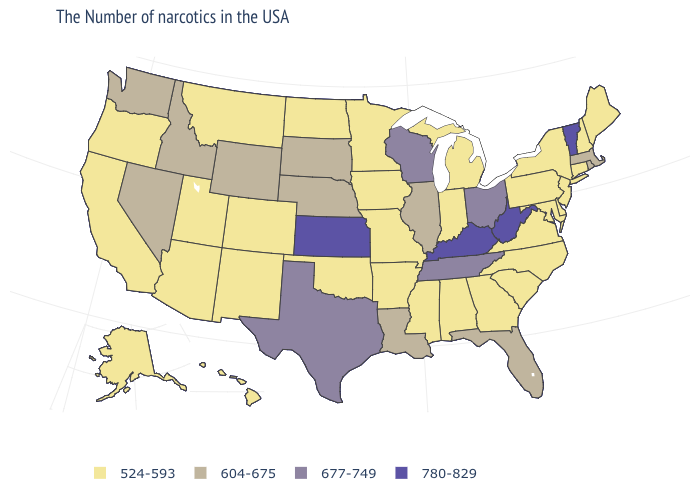What is the lowest value in the South?
Quick response, please. 524-593. How many symbols are there in the legend?
Answer briefly. 4. What is the lowest value in the West?
Quick response, please. 524-593. What is the highest value in the USA?
Short answer required. 780-829. What is the value of Montana?
Write a very short answer. 524-593. What is the highest value in the USA?
Concise answer only. 780-829. Does Delaware have the lowest value in the South?
Write a very short answer. Yes. Among the states that border Michigan , which have the highest value?
Be succinct. Ohio, Wisconsin. What is the value of Washington?
Short answer required. 604-675. What is the value of Alaska?
Short answer required. 524-593. Which states have the lowest value in the USA?
Short answer required. Maine, New Hampshire, Connecticut, New York, New Jersey, Delaware, Maryland, Pennsylvania, Virginia, North Carolina, South Carolina, Georgia, Michigan, Indiana, Alabama, Mississippi, Missouri, Arkansas, Minnesota, Iowa, Oklahoma, North Dakota, Colorado, New Mexico, Utah, Montana, Arizona, California, Oregon, Alaska, Hawaii. Does Tennessee have the same value as Wisconsin?
Concise answer only. Yes. Name the states that have a value in the range 604-675?
Short answer required. Massachusetts, Rhode Island, Florida, Illinois, Louisiana, Nebraska, South Dakota, Wyoming, Idaho, Nevada, Washington. Among the states that border Minnesota , which have the highest value?
Give a very brief answer. Wisconsin. 